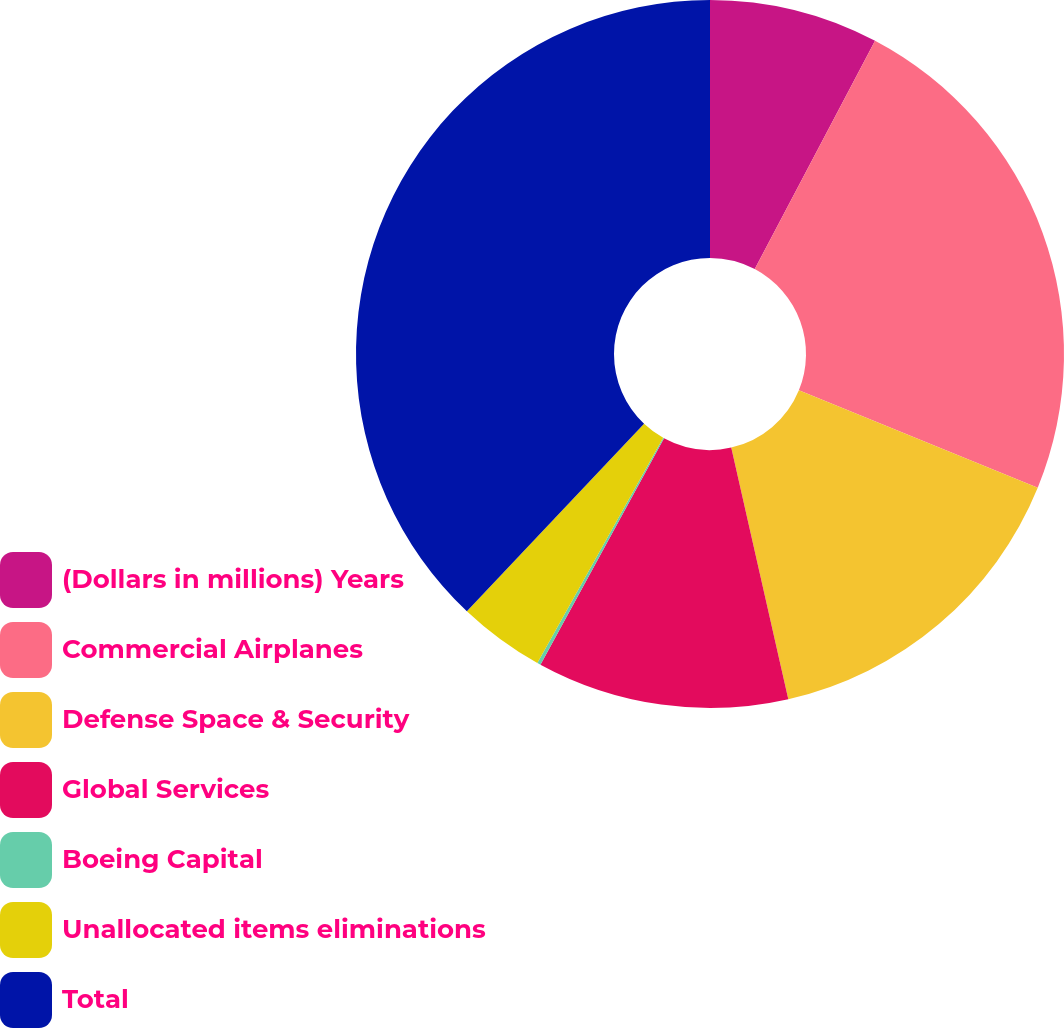Convert chart to OTSL. <chart><loc_0><loc_0><loc_500><loc_500><pie_chart><fcel>(Dollars in millions) Years<fcel>Commercial Airplanes<fcel>Defense Space & Security<fcel>Global Services<fcel>Boeing Capital<fcel>Unallocated items eliminations<fcel>Total<nl><fcel>7.72%<fcel>23.45%<fcel>15.28%<fcel>11.5%<fcel>0.16%<fcel>3.94%<fcel>37.95%<nl></chart> 